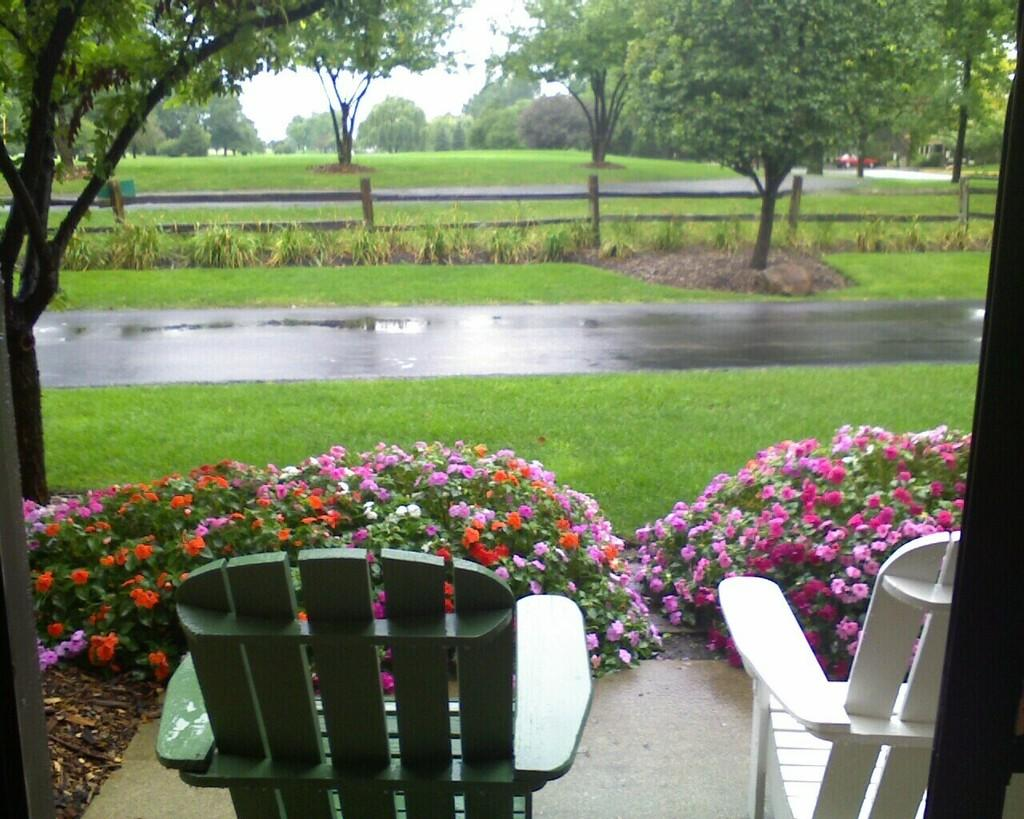What type of furniture is located at the bottom of the image? There are chairs at the bottom of the image. What type of vegetation can be seen in the image? There are shrubs, flowers, trees, and grass visible in the image. What is in the background of the image? There is a fence, trees, grass, and the sky visible in the background of the image. What type of gold ornament is hanging from the fence in the image? There is no gold ornament present in the image; the fence is not adorned with any decorations. Can you tell me how many knives are lying on the grass in the image? There are no knives present in the image; the grass is not shown to have any sharp objects. 